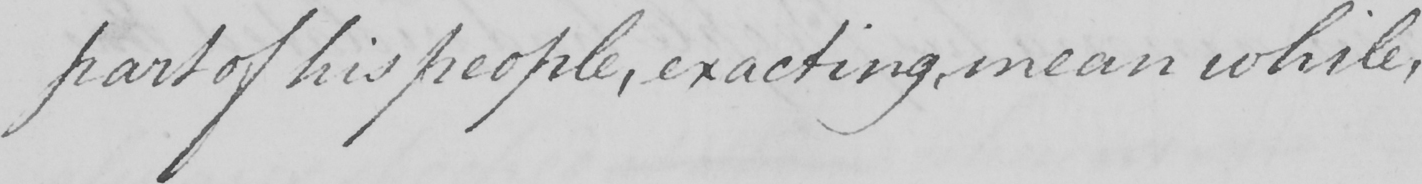Please transcribe the handwritten text in this image. part of his people , exacting , mean while , 